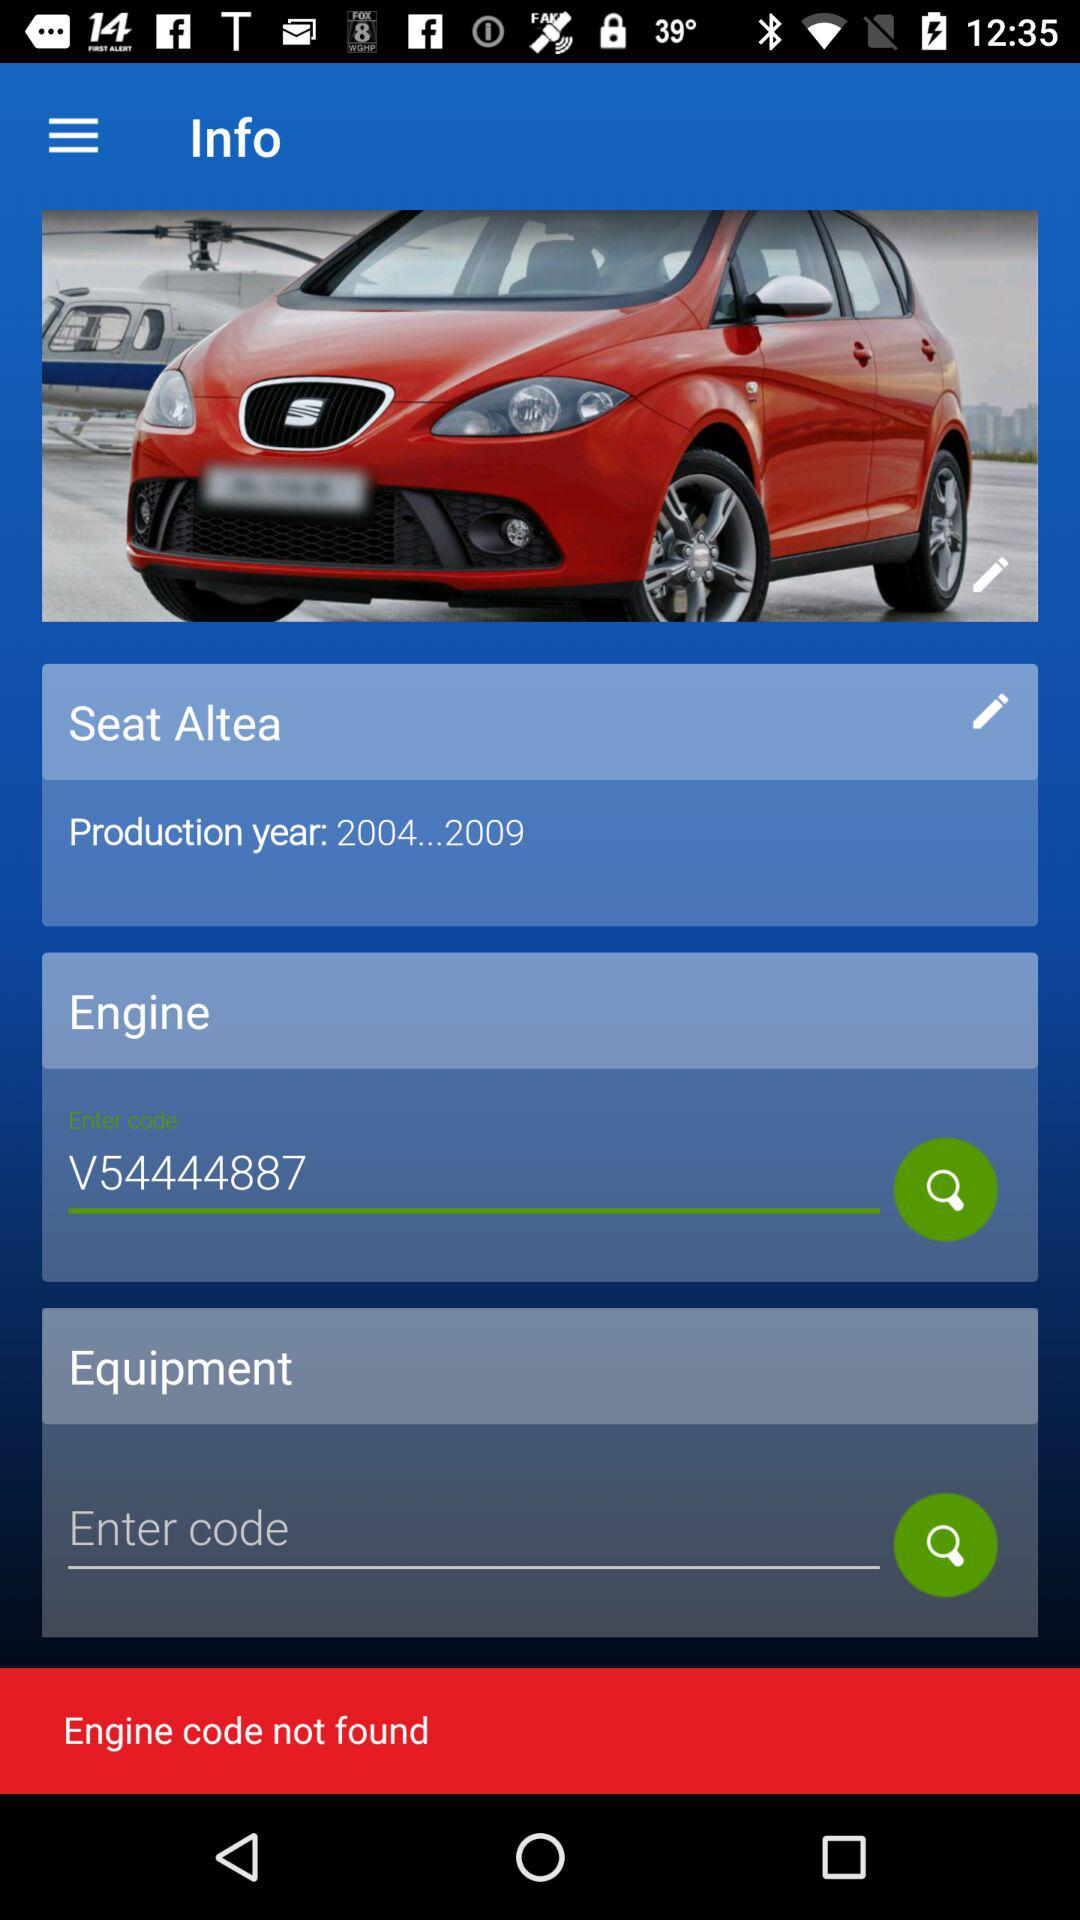What is engine code? The engine code is V54444887. 